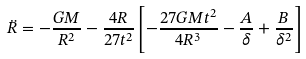<formula> <loc_0><loc_0><loc_500><loc_500>\ddot { R } = - \frac { G M } { R ^ { 2 } } - \frac { 4 R } { 2 7 t ^ { 2 } } \left [ - \frac { 2 7 G M t ^ { 2 } } { 4 R ^ { 3 } } - \frac { A } { \delta } + \frac { B } { \delta ^ { 2 } } \right ]</formula> 